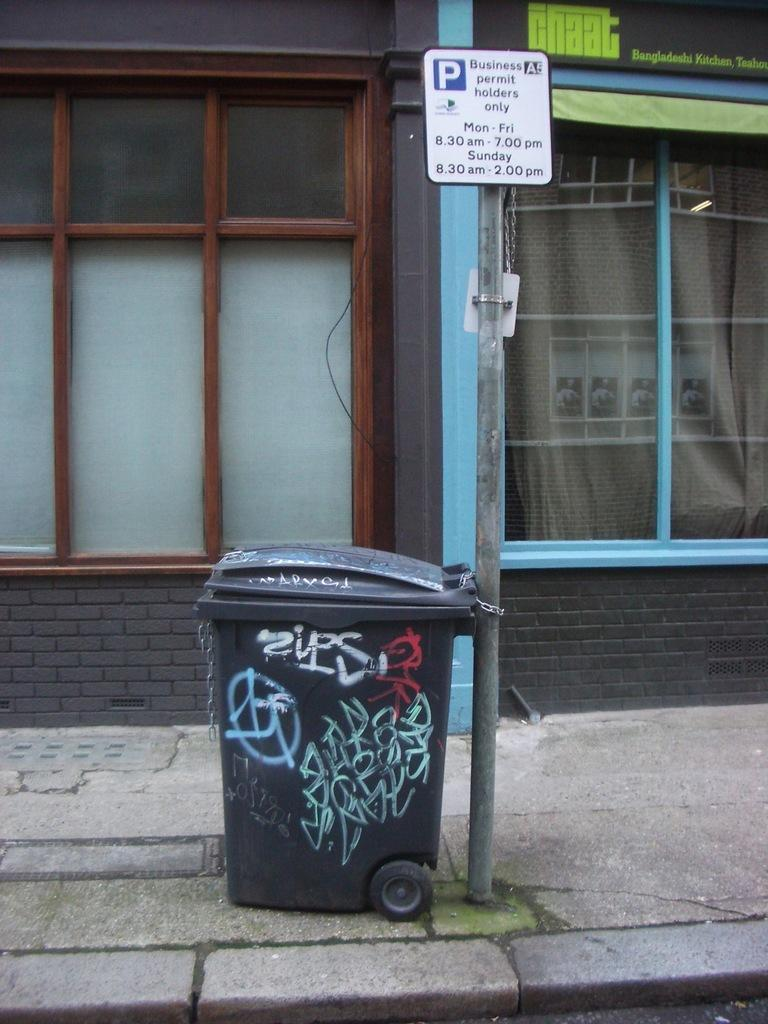What object is present in the image that is used for waste disposal? There is a dustbin in the image. How is the dustbin secured in the image? The dustbin is tied to a sign board. What type of structure is located beside the dustbin and sign board? There are windows beside the dustbin and sign board. What type of credit can be seen on the dustbin in the image? There is no credit or any financial information present on the dustbin in the image. 